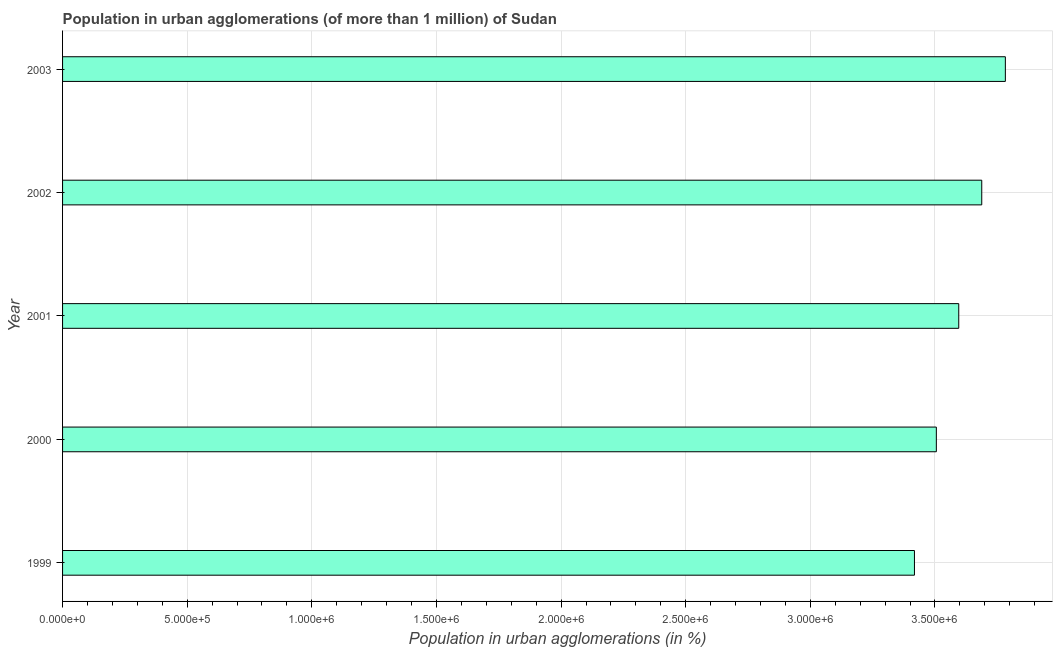Does the graph contain grids?
Keep it short and to the point. Yes. What is the title of the graph?
Give a very brief answer. Population in urban agglomerations (of more than 1 million) of Sudan. What is the label or title of the X-axis?
Your answer should be compact. Population in urban agglomerations (in %). What is the label or title of the Y-axis?
Give a very brief answer. Year. What is the population in urban agglomerations in 2001?
Give a very brief answer. 3.60e+06. Across all years, what is the maximum population in urban agglomerations?
Keep it short and to the point. 3.78e+06. Across all years, what is the minimum population in urban agglomerations?
Offer a very short reply. 3.42e+06. In which year was the population in urban agglomerations minimum?
Keep it short and to the point. 1999. What is the sum of the population in urban agglomerations?
Offer a terse response. 1.80e+07. What is the difference between the population in urban agglomerations in 2001 and 2003?
Keep it short and to the point. -1.87e+05. What is the average population in urban agglomerations per year?
Provide a short and direct response. 3.60e+06. What is the median population in urban agglomerations?
Ensure brevity in your answer.  3.60e+06. In how many years, is the population in urban agglomerations greater than 200000 %?
Keep it short and to the point. 5. Do a majority of the years between 2003 and 2000 (inclusive) have population in urban agglomerations greater than 900000 %?
Your response must be concise. Yes. What is the ratio of the population in urban agglomerations in 2000 to that in 2001?
Offer a very short reply. 0.97. What is the difference between the highest and the second highest population in urban agglomerations?
Offer a very short reply. 9.47e+04. Is the sum of the population in urban agglomerations in 2000 and 2003 greater than the maximum population in urban agglomerations across all years?
Make the answer very short. Yes. What is the difference between the highest and the lowest population in urban agglomerations?
Your answer should be very brief. 3.65e+05. What is the Population in urban agglomerations (in %) in 1999?
Provide a succinct answer. 3.42e+06. What is the Population in urban agglomerations (in %) in 2000?
Offer a terse response. 3.51e+06. What is the Population in urban agglomerations (in %) of 2001?
Keep it short and to the point. 3.60e+06. What is the Population in urban agglomerations (in %) in 2002?
Make the answer very short. 3.69e+06. What is the Population in urban agglomerations (in %) of 2003?
Your response must be concise. 3.78e+06. What is the difference between the Population in urban agglomerations (in %) in 1999 and 2000?
Give a very brief answer. -8.79e+04. What is the difference between the Population in urban agglomerations (in %) in 1999 and 2001?
Your answer should be very brief. -1.78e+05. What is the difference between the Population in urban agglomerations (in %) in 1999 and 2002?
Provide a short and direct response. -2.70e+05. What is the difference between the Population in urban agglomerations (in %) in 1999 and 2003?
Offer a very short reply. -3.65e+05. What is the difference between the Population in urban agglomerations (in %) in 2000 and 2001?
Your answer should be compact. -8.99e+04. What is the difference between the Population in urban agglomerations (in %) in 2000 and 2002?
Make the answer very short. -1.82e+05. What is the difference between the Population in urban agglomerations (in %) in 2000 and 2003?
Offer a very short reply. -2.77e+05. What is the difference between the Population in urban agglomerations (in %) in 2001 and 2002?
Ensure brevity in your answer.  -9.23e+04. What is the difference between the Population in urban agglomerations (in %) in 2001 and 2003?
Your answer should be compact. -1.87e+05. What is the difference between the Population in urban agglomerations (in %) in 2002 and 2003?
Provide a succinct answer. -9.47e+04. What is the ratio of the Population in urban agglomerations (in %) in 1999 to that in 2001?
Ensure brevity in your answer.  0.95. What is the ratio of the Population in urban agglomerations (in %) in 1999 to that in 2002?
Provide a succinct answer. 0.93. What is the ratio of the Population in urban agglomerations (in %) in 1999 to that in 2003?
Provide a succinct answer. 0.9. What is the ratio of the Population in urban agglomerations (in %) in 2000 to that in 2001?
Ensure brevity in your answer.  0.97. What is the ratio of the Population in urban agglomerations (in %) in 2000 to that in 2002?
Make the answer very short. 0.95. What is the ratio of the Population in urban agglomerations (in %) in 2000 to that in 2003?
Offer a very short reply. 0.93. What is the ratio of the Population in urban agglomerations (in %) in 2001 to that in 2003?
Make the answer very short. 0.95. What is the ratio of the Population in urban agglomerations (in %) in 2002 to that in 2003?
Your response must be concise. 0.97. 